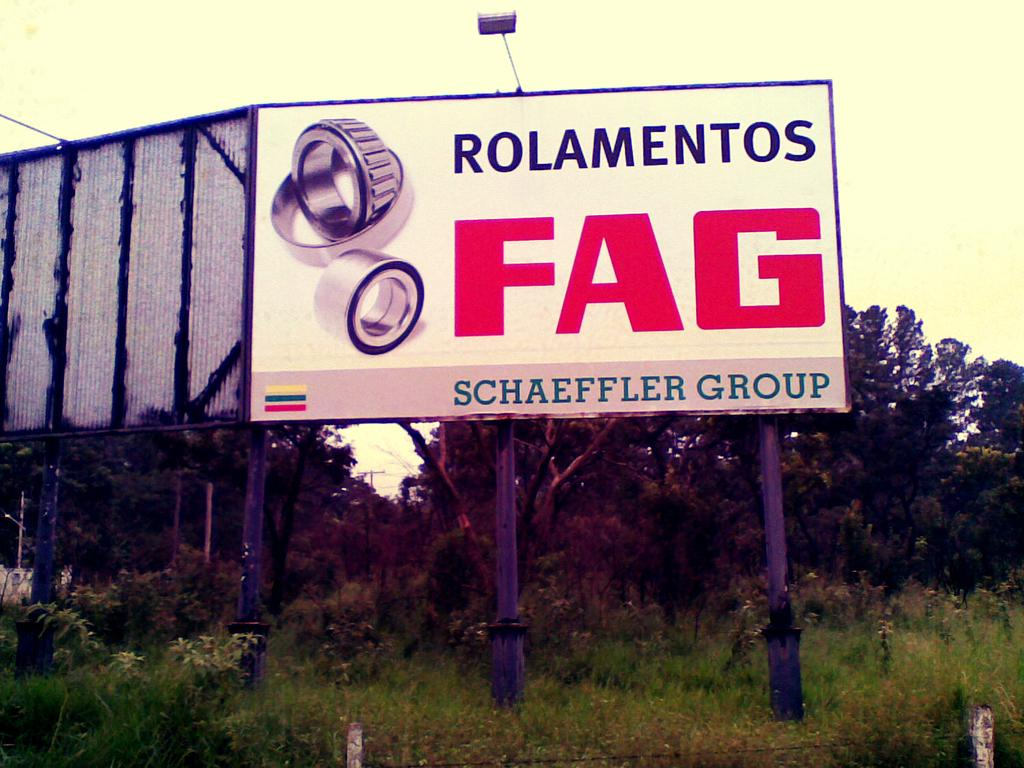<image>
Offer a succinct explanation of the picture presented. A sign by Schaeffer Group advertising some car parts. 